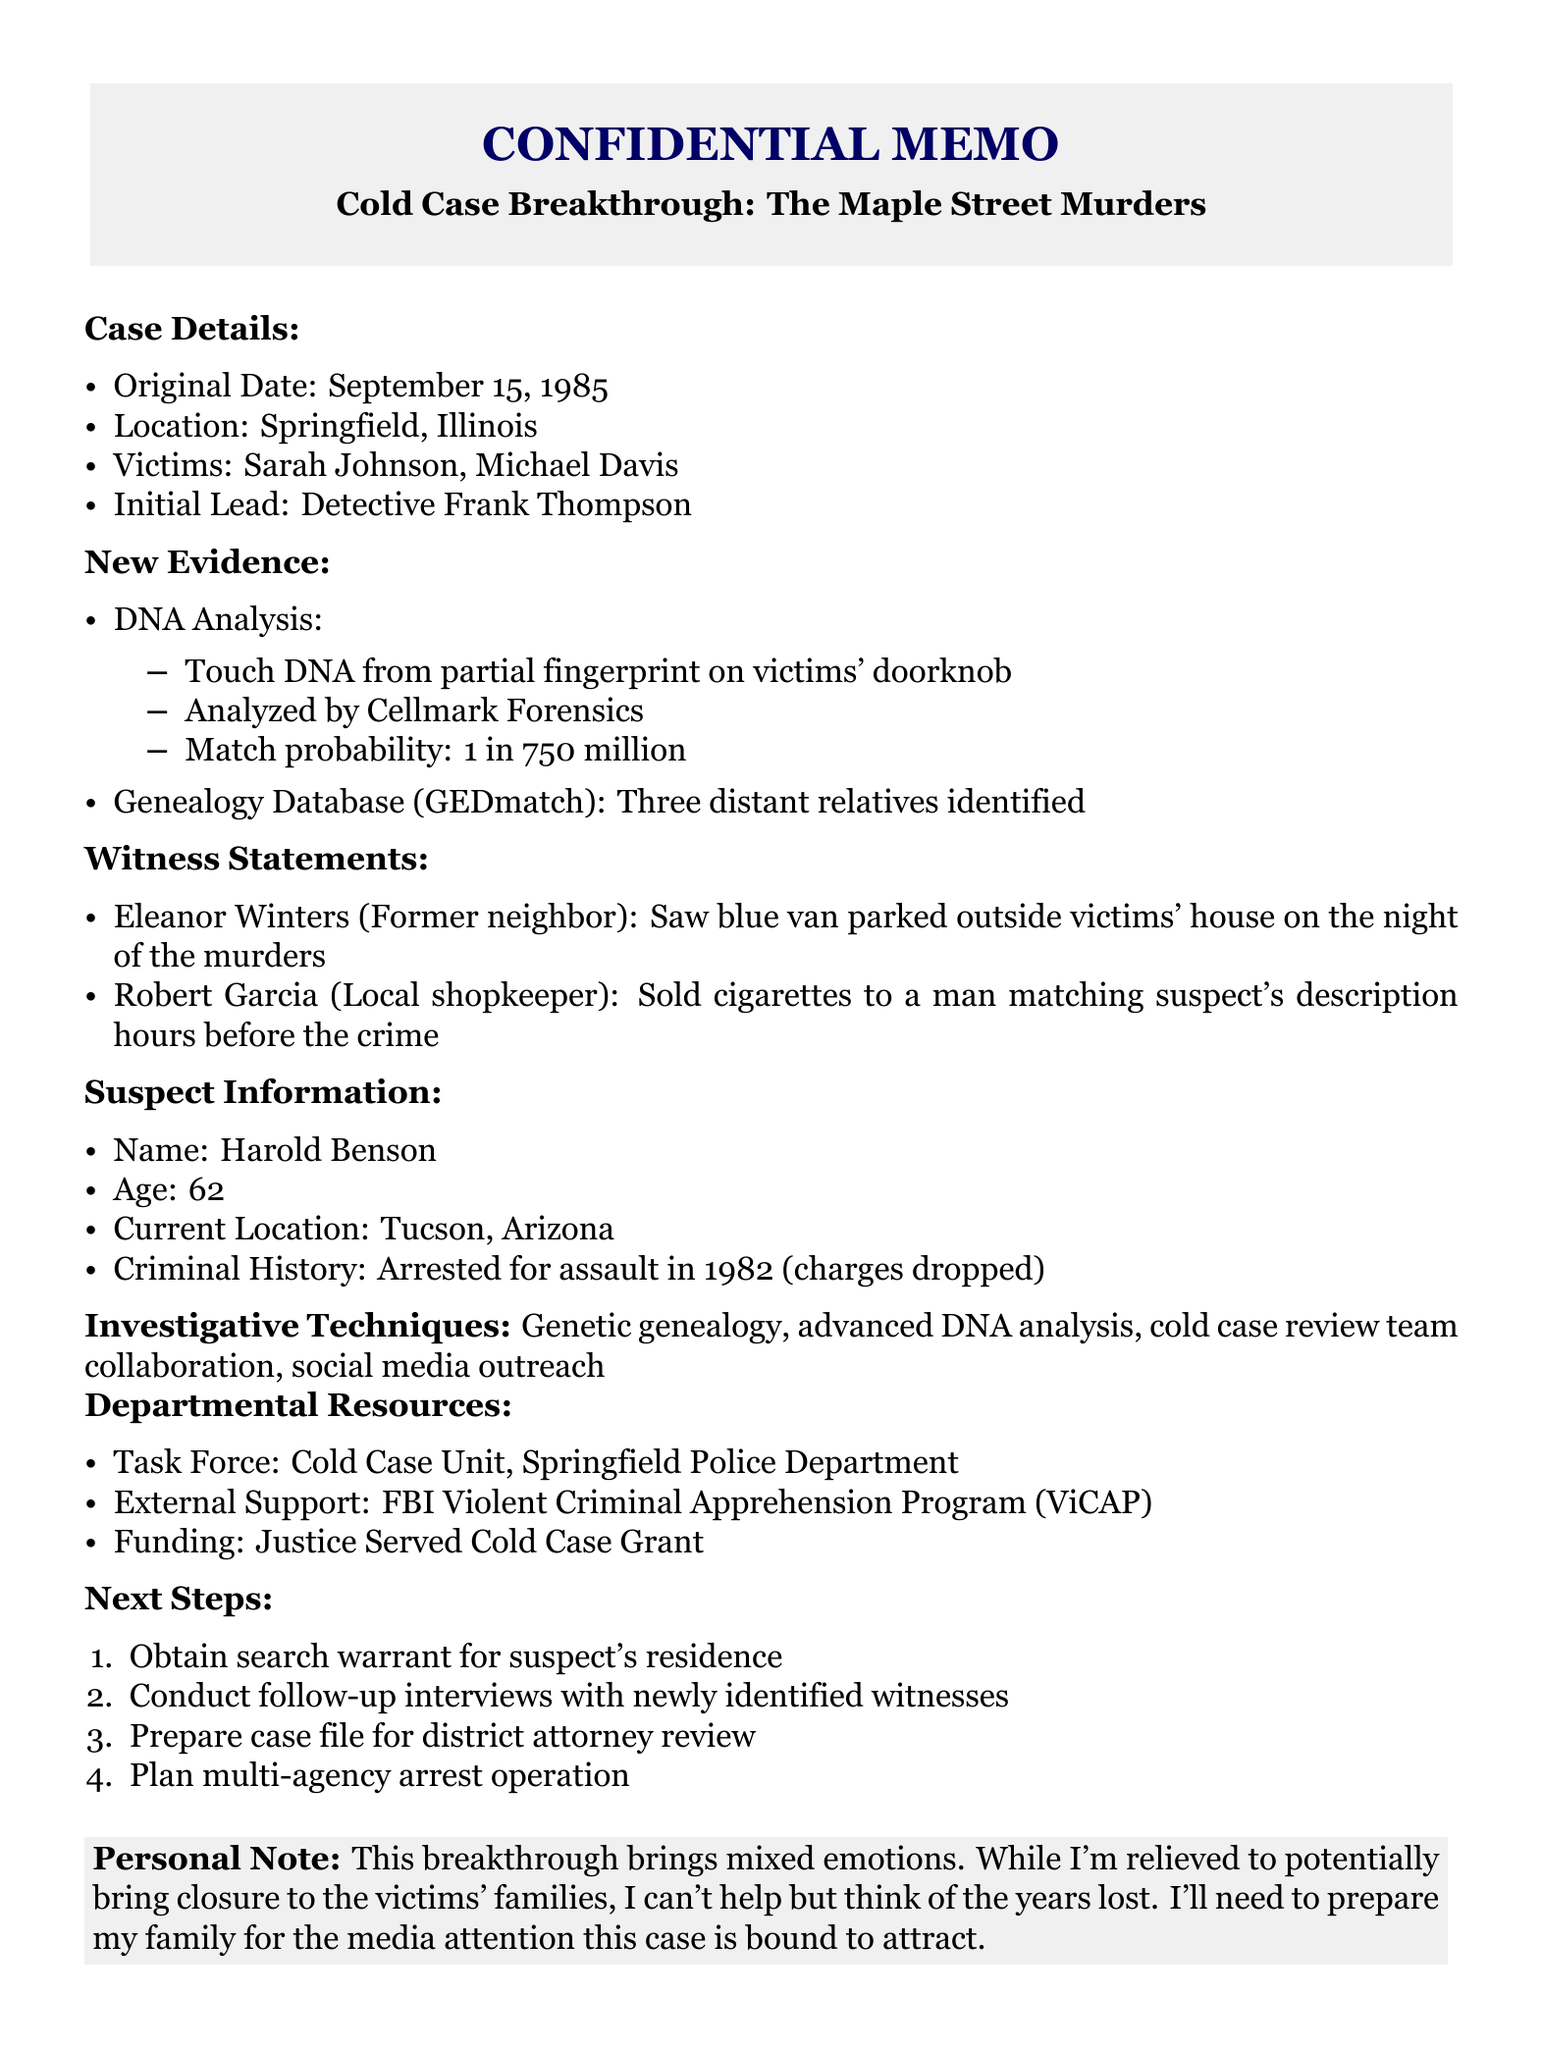What is the original date of the case? The original date is specified in the case details section of the document.
Answer: September 15, 1985 What type of DNA analysis was conducted? The type of DNA analysis is detailed under the new evidence section of the document.
Answer: Touch DNA What is the match probability of the DNA evidence? The match probability is provided in the new DNA analysis section.
Answer: 1 in 750 million Who was the initial investigation lead? The initial investigation lead is mentioned in the case details section.
Answer: Detective Frank Thompson What was Eleanor Winters' observation? Eleanor Winters' statement can be found in the witness statements section of the document.
Answer: Blue van parked outside victims' house How many distant relatives were identified through the genealogy database? The number of distant relatives identified is included in the new evidence section.
Answer: Three What are the next steps listed in the memo? The next steps provide specific actions to be taken following the new evidence, indicated in the next steps section.
Answer: Obtain search warrant for suspect's residence What feelings does the detective express in the personal note? The personal note summarizes the detective's emotional reaction to the breakthrough in the case.
Answer: Mixed emotions 